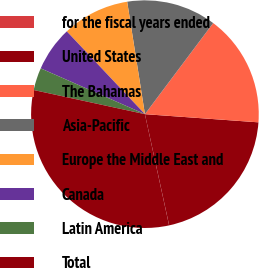Convert chart to OTSL. <chart><loc_0><loc_0><loc_500><loc_500><pie_chart><fcel>for the fiscal years ended<fcel>United States<fcel>The Bahamas<fcel>Asia-Pacific<fcel>Europe the Middle East and<fcel>Canada<fcel>Latin America<fcel>Total<nl><fcel>0.01%<fcel>20.44%<fcel>15.91%<fcel>12.73%<fcel>9.55%<fcel>6.37%<fcel>3.19%<fcel>31.81%<nl></chart> 